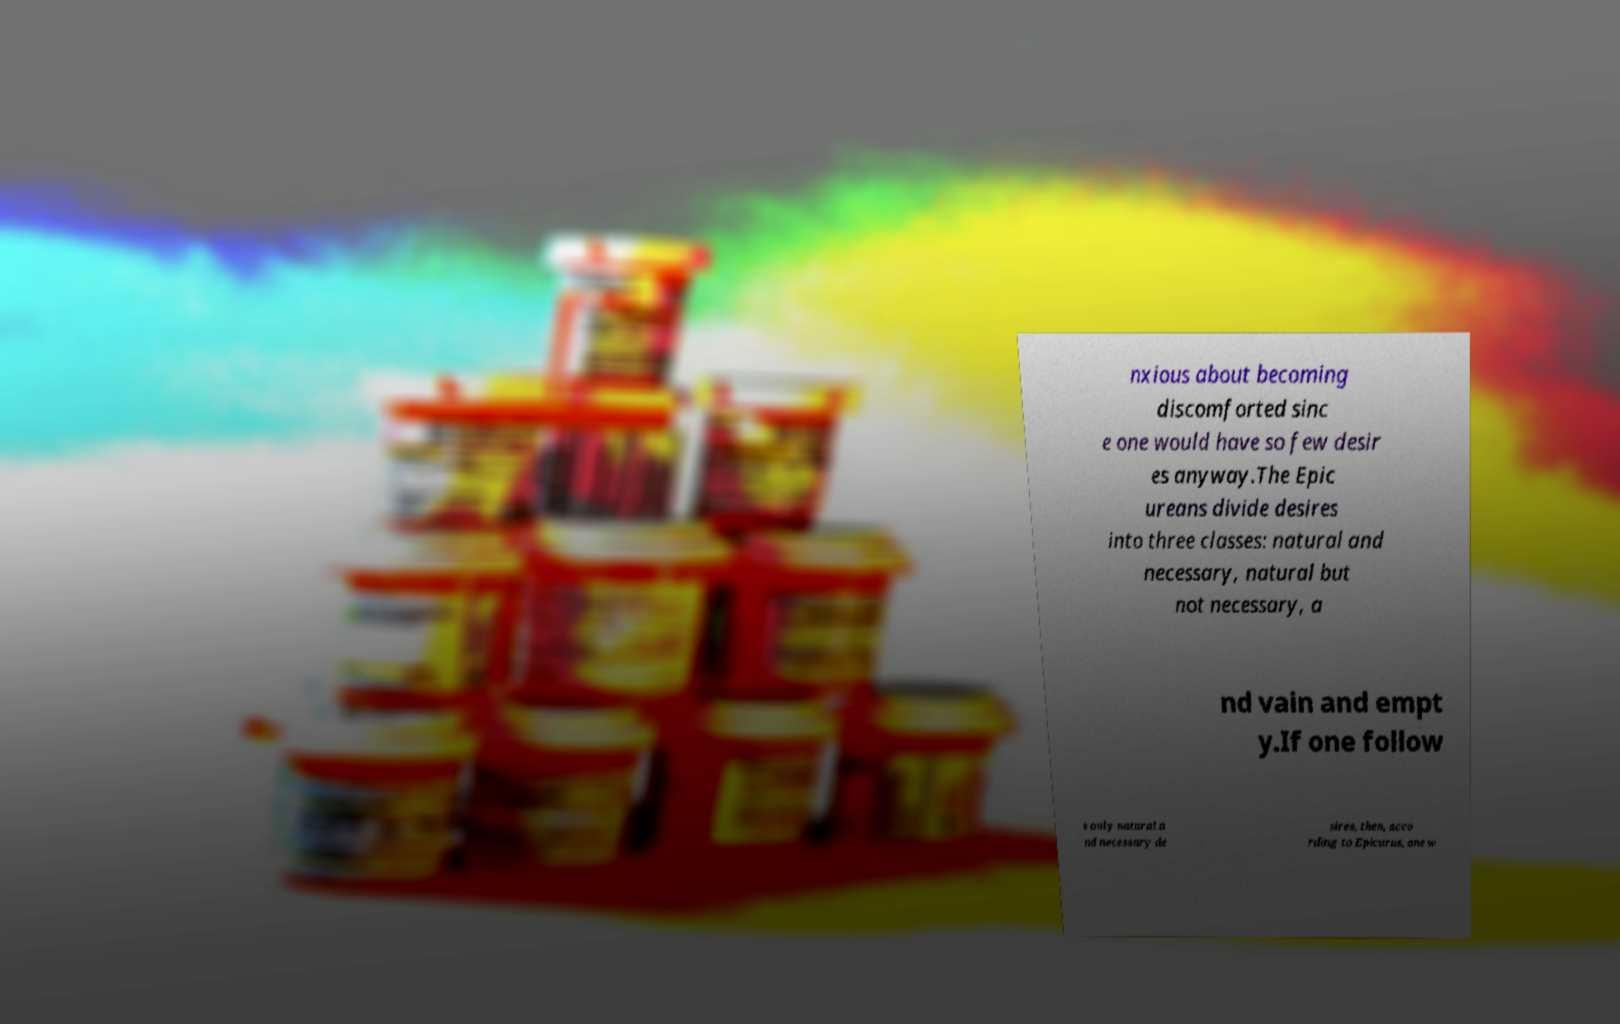Please read and relay the text visible in this image. What does it say? nxious about becoming discomforted sinc e one would have so few desir es anyway.The Epic ureans divide desires into three classes: natural and necessary, natural but not necessary, a nd vain and empt y.If one follow s only natural a nd necessary de sires, then, acco rding to Epicurus, one w 